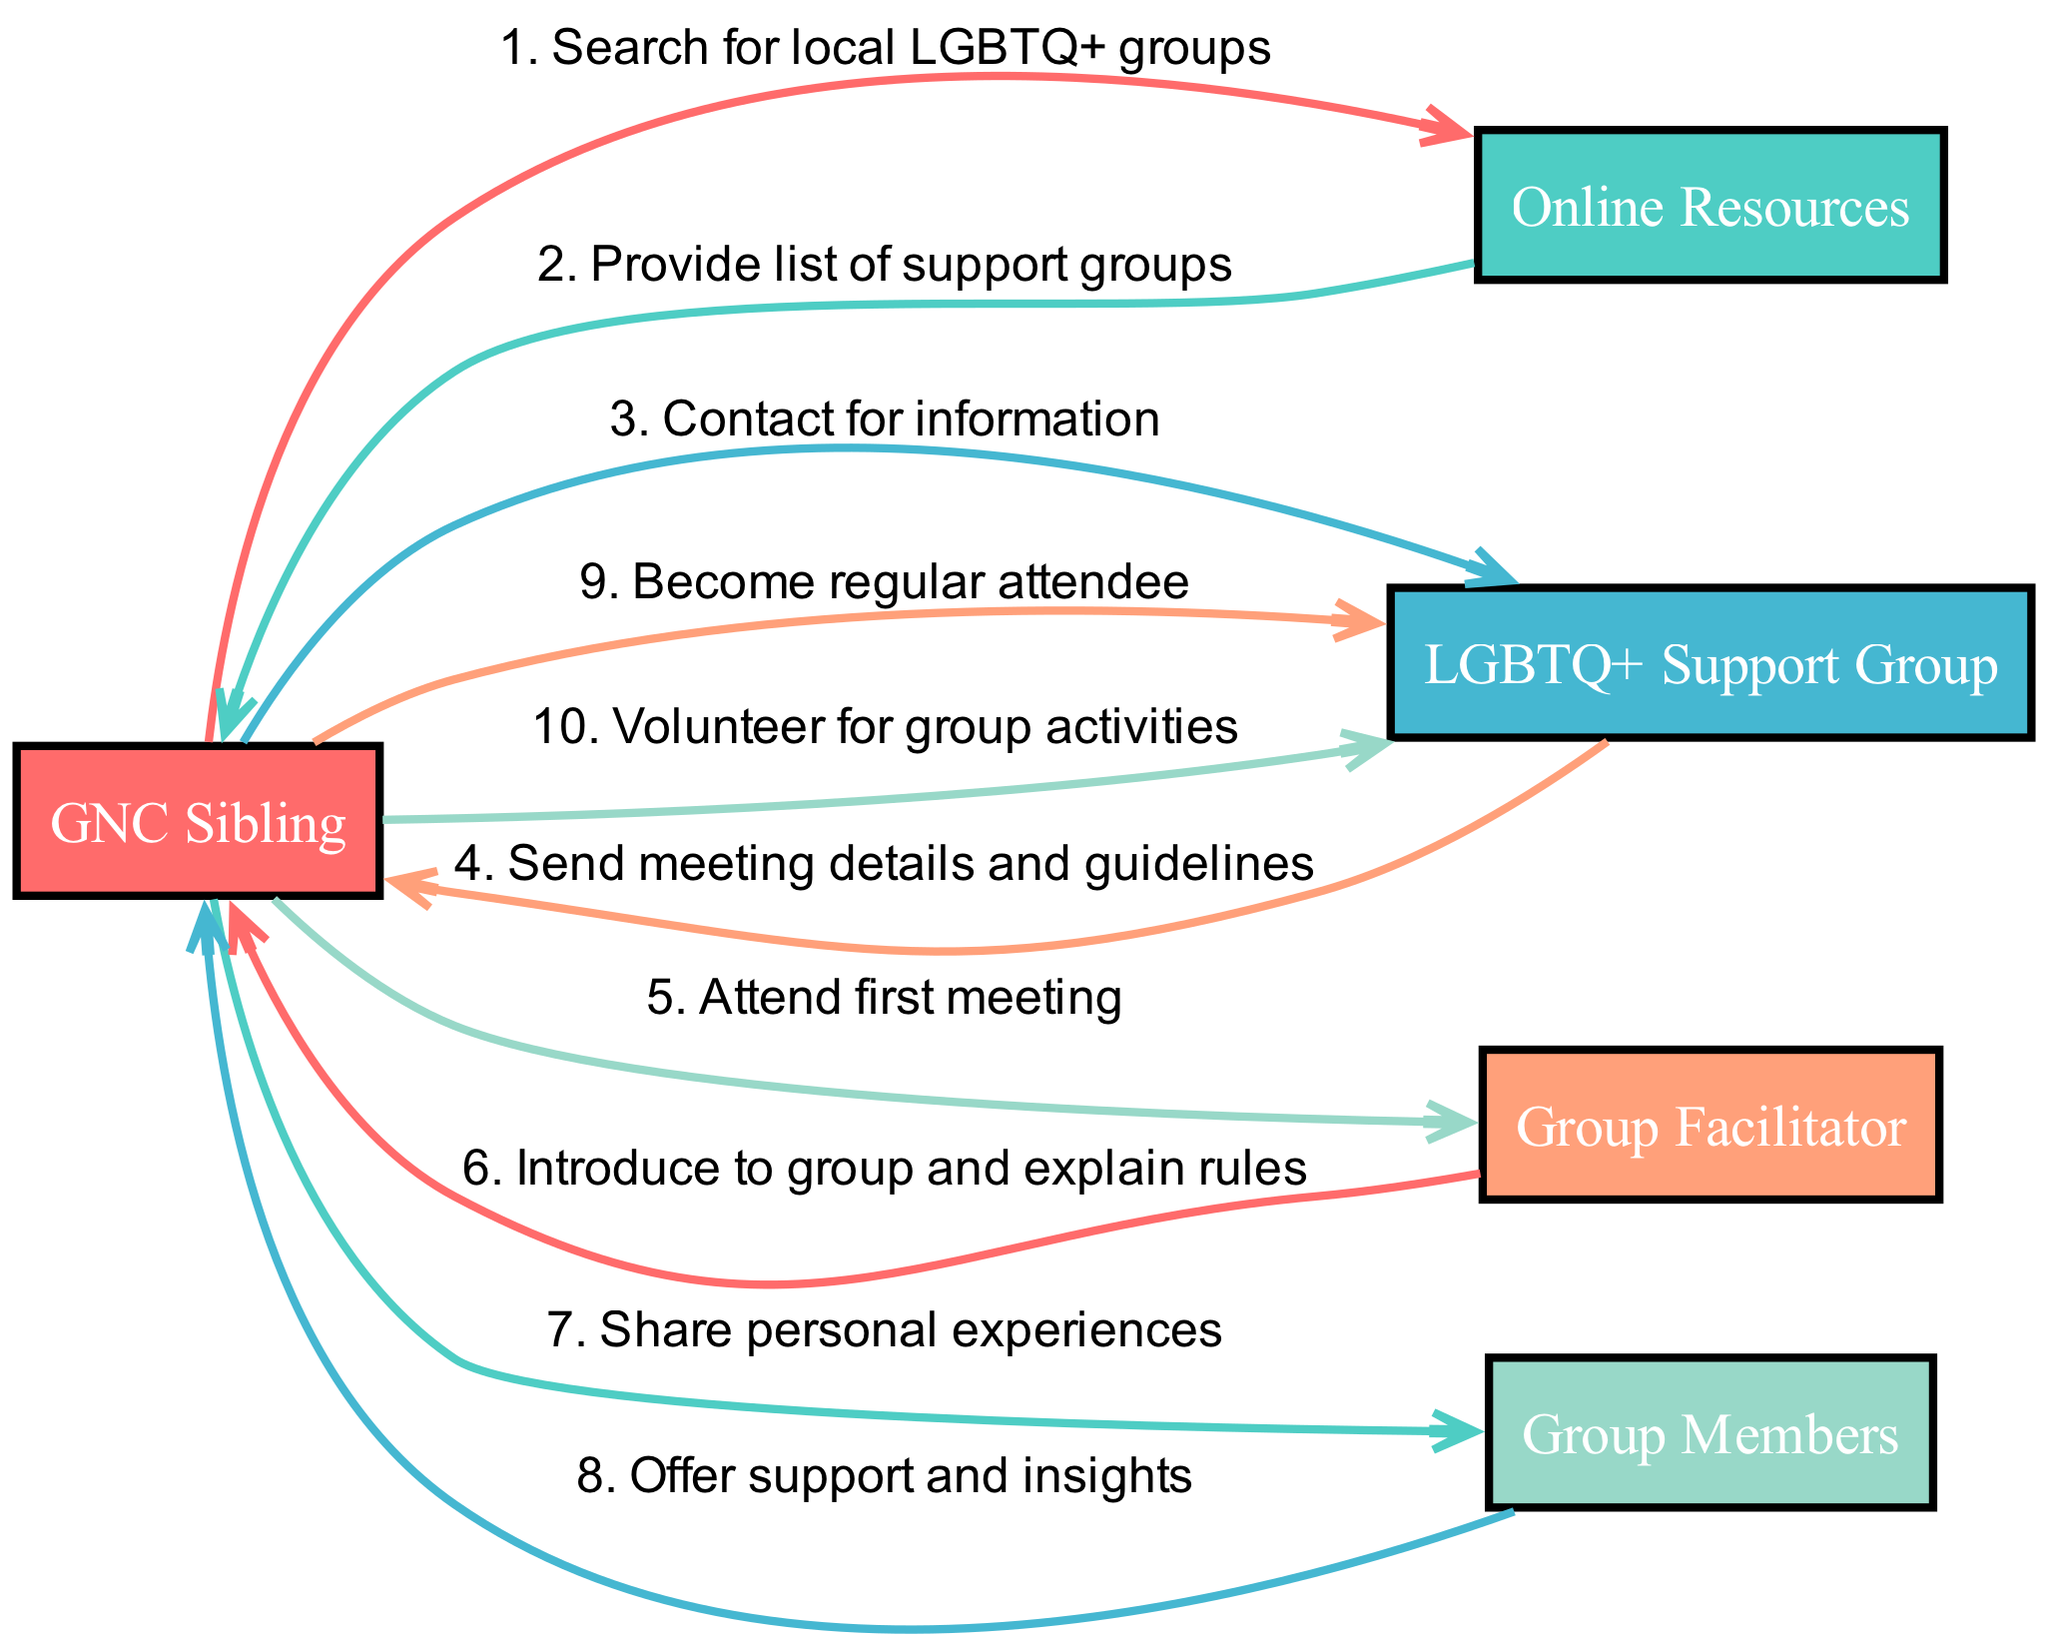What is the first action taken by the GNC Sibling? The sequence starts with the GNC Sibling searching for local LGBTQ+ groups. This is the first step noted in the diagram.
Answer: Search for local LGBTQ+ groups How many actors are involved in this sequence diagram? By counting the unique actors listed in the diagram, there are five actors: GNC Sibling, Online Resources, LGBTQ+ Support Group, Group Facilitator, and Group Members.
Answer: 5 What do the Online Resources provide to the GNC Sibling? The Online Resources provide a list of support groups, which is the second action in the sequence.
Answer: Provide list of support groups Which actor does the GNC Sibling contact for information? The GNC Sibling contacts the LGBTQ+ Support Group to gather more information, as indicated in the diagram.
Answer: LGBTQ+ Support Group What action follows after the GNC Sibling attends the first meeting? After the GNC Sibling attends the first meeting, the Group Facilitator introduces them to the group and explains the rules. This follows sequentially in the diagram.
Answer: Introduce to group and explain rules How many actions does the GNC Sibling take before becoming a regular attendee? The GNC Sibling takes three actions before becoming a regular attendee: contacting the LGBTQ+ Support Group, attending the first meeting, and sharing personal experiences with Group Members.
Answer: 3 Who offers support and insights to the GNC Sibling? The Group Members offer support and insights to the GNC Sibling after they share their personal experiences. This is evident in the interaction noted in the diagram.
Answer: Group Members What does the GNC Sibling do after becoming a regular attendee? After becoming a regular attendee, the GNC Sibling volunteers for group activities, as presented in the final action of the sequence.
Answer: Volunteer for group activities 